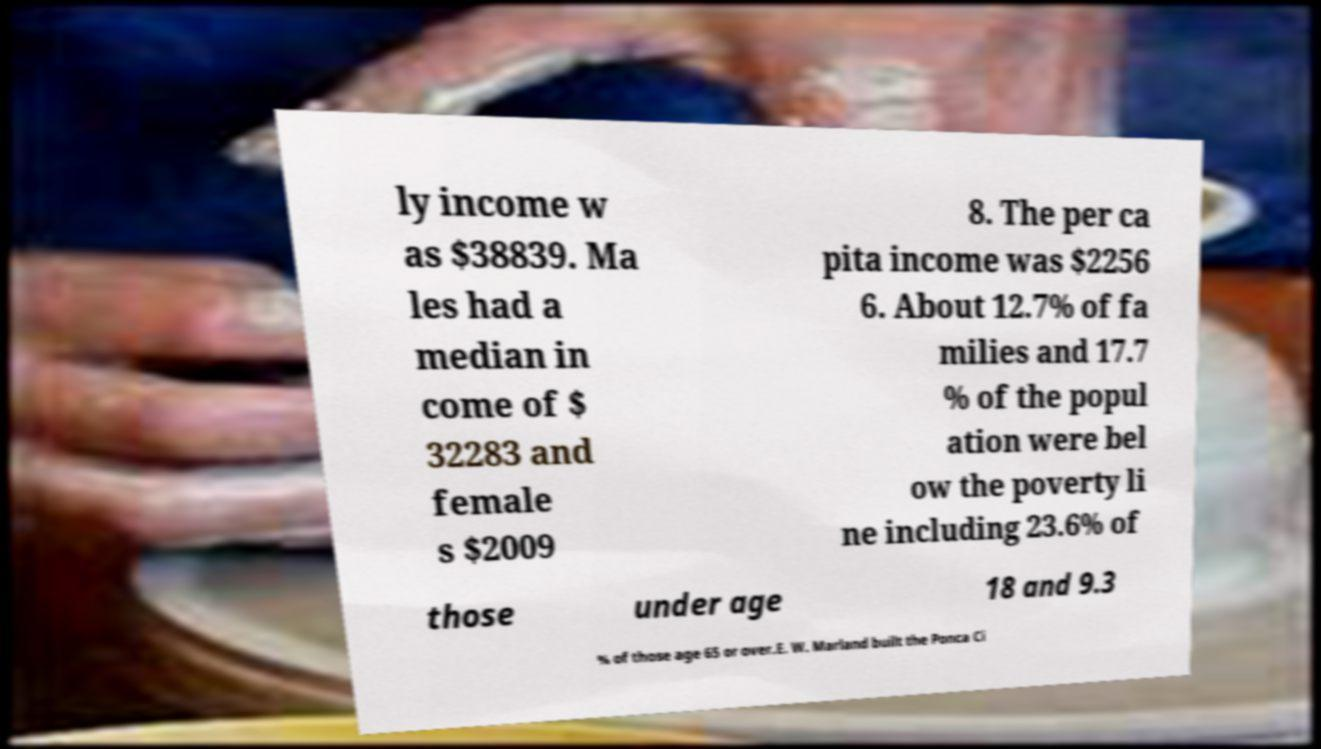Please read and relay the text visible in this image. What does it say? ly income w as $38839. Ma les had a median in come of $ 32283 and female s $2009 8. The per ca pita income was $2256 6. About 12.7% of fa milies and 17.7 % of the popul ation were bel ow the poverty li ne including 23.6% of those under age 18 and 9.3 % of those age 65 or over.E. W. Marland built the Ponca Ci 